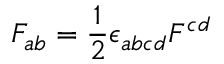<formula> <loc_0><loc_0><loc_500><loc_500>F _ { a b } = { \frac { 1 } { 2 } } \epsilon _ { a b c d } F ^ { c d }</formula> 